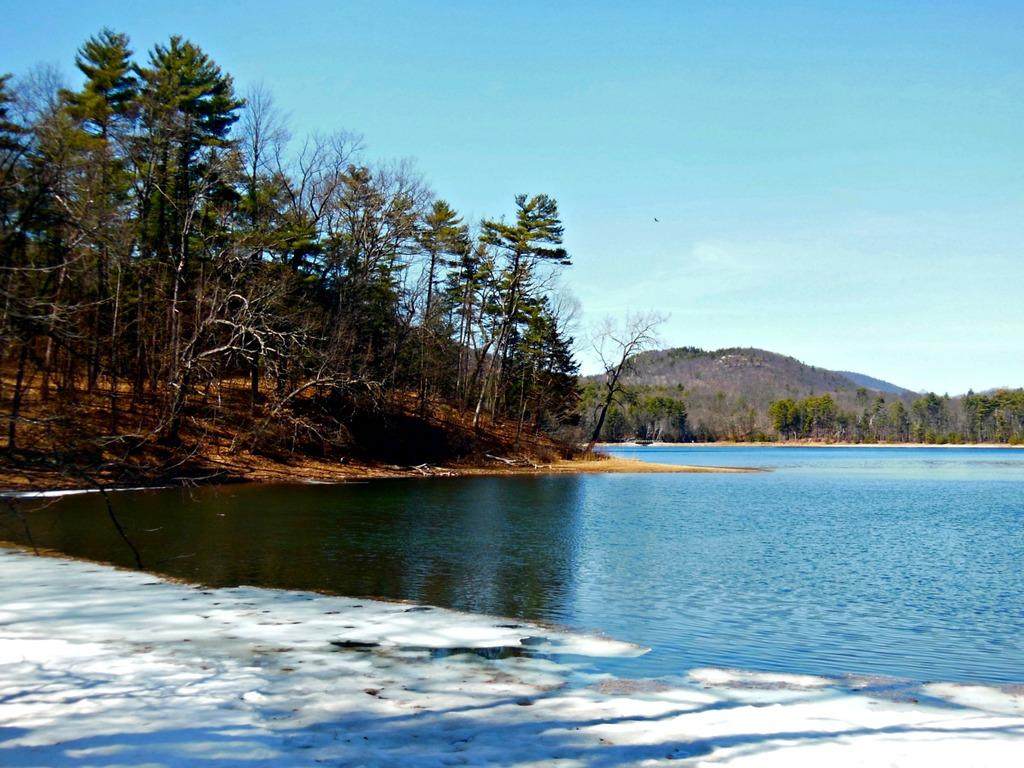What type of vegetation can be seen in the image? There are trees in the image. What geographical feature is present in the image? There is a hill in the image. What natural element is visible in the image? There is water visible in the image. How would you describe the sky in the image? The sky is blue and cloudy. How many bikes are being smashed by the water in the image? There are no bikes present in the image, and therefore no bikes are being smashed by the water. Can you see any planes flying over the hill in the image? There are no planes visible in the image. 